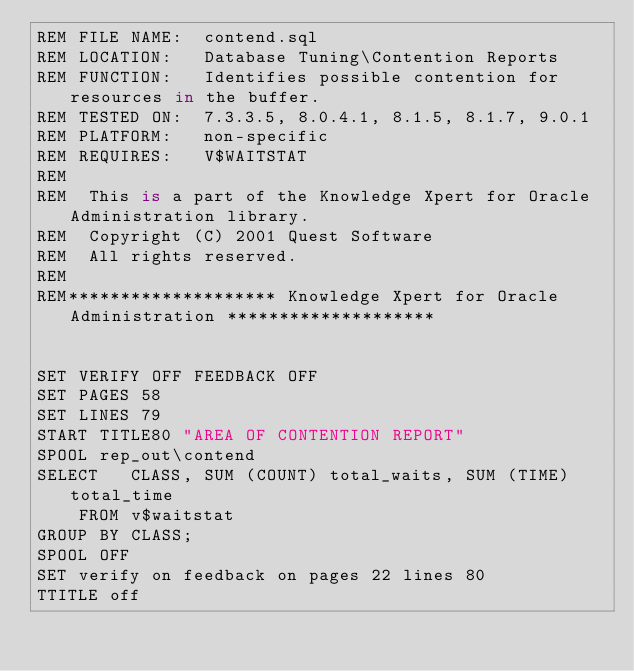<code> <loc_0><loc_0><loc_500><loc_500><_SQL_>REM FILE NAME:  contend.sql
REM LOCATION:   Database Tuning\Contention Reports
REM FUNCTION:   Identifies possible contention for resources in the buffer.
REM TESTED ON:  7.3.3.5, 8.0.4.1, 8.1.5, 8.1.7, 9.0.1
REM PLATFORM:   non-specific
REM REQUIRES:   V$WAITSTAT 
REM
REM  This is a part of the Knowledge Xpert for Oracle Administration library. 
REM  Copyright (C) 2001 Quest Software 
REM  All rights reserved. 
REM 
REM******************** Knowledge Xpert for Oracle Administration ********************


SET VERIFY OFF FEEDBACK OFF  
SET PAGES 58 
SET LINES 79 
START TITLE80 "AREA OF CONTENTION REPORT" 
SPOOL rep_out\contend
SELECT   CLASS, SUM (COUNT) total_waits, SUM (TIME) total_time
    FROM v$waitstat
GROUP BY CLASS;
SPOOL OFF 
SET verify on feedback on pages 22 lines 80
TTITLE off
</code> 